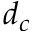<formula> <loc_0><loc_0><loc_500><loc_500>d _ { c }</formula> 